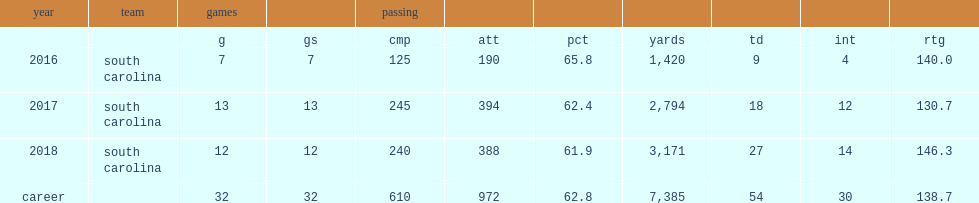How many touchdowns did bentley throw with 2,794 yards passing in 2017? 18.0. 